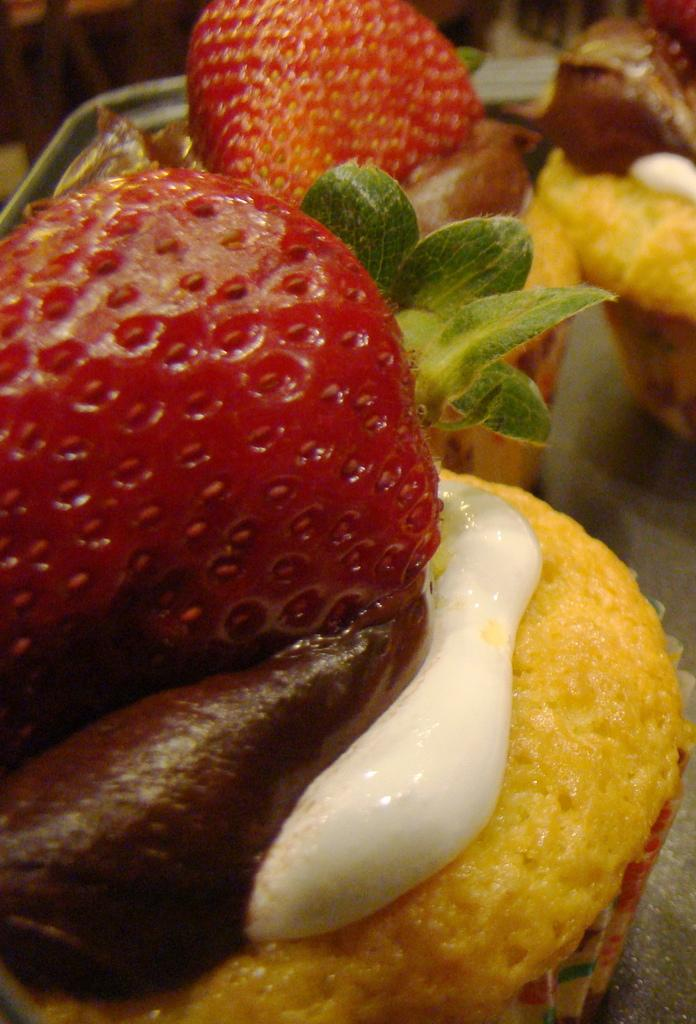What type of dessert can be seen in the image? There are cupcakes in the image. What topping is featured on the cupcakes? There are strawberries on the cupcakes. What is the account number of the carriage in the image? There is no carriage present in the image, so there is no account number to provide. 